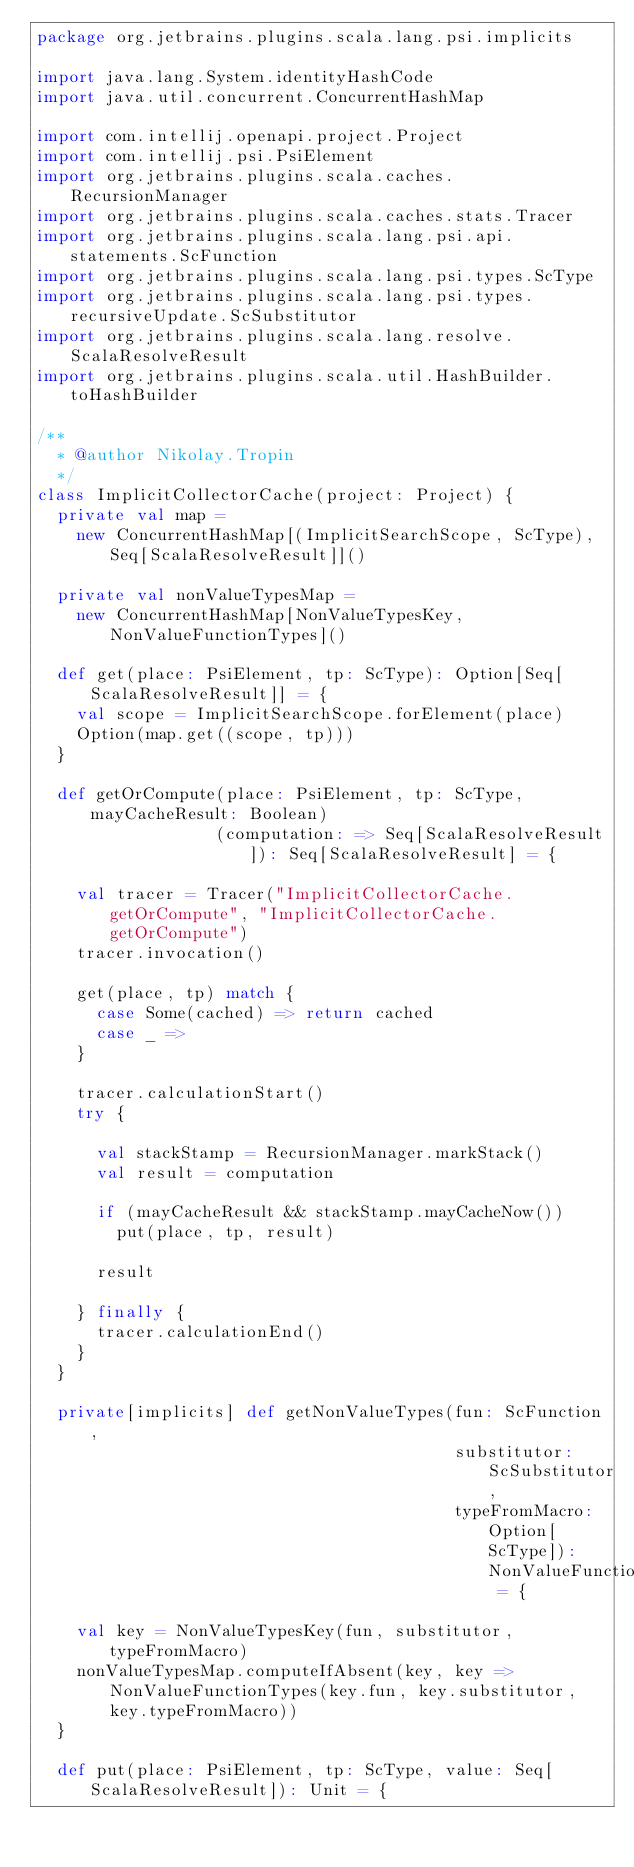Convert code to text. <code><loc_0><loc_0><loc_500><loc_500><_Scala_>package org.jetbrains.plugins.scala.lang.psi.implicits

import java.lang.System.identityHashCode
import java.util.concurrent.ConcurrentHashMap

import com.intellij.openapi.project.Project
import com.intellij.psi.PsiElement
import org.jetbrains.plugins.scala.caches.RecursionManager
import org.jetbrains.plugins.scala.caches.stats.Tracer
import org.jetbrains.plugins.scala.lang.psi.api.statements.ScFunction
import org.jetbrains.plugins.scala.lang.psi.types.ScType
import org.jetbrains.plugins.scala.lang.psi.types.recursiveUpdate.ScSubstitutor
import org.jetbrains.plugins.scala.lang.resolve.ScalaResolveResult
import org.jetbrains.plugins.scala.util.HashBuilder.toHashBuilder

/**
  * @author Nikolay.Tropin
  */
class ImplicitCollectorCache(project: Project) {
  private val map =
    new ConcurrentHashMap[(ImplicitSearchScope, ScType), Seq[ScalaResolveResult]]()

  private val nonValueTypesMap =
    new ConcurrentHashMap[NonValueTypesKey, NonValueFunctionTypes]()

  def get(place: PsiElement, tp: ScType): Option[Seq[ScalaResolveResult]] = {
    val scope = ImplicitSearchScope.forElement(place)
    Option(map.get((scope, tp)))
  }

  def getOrCompute(place: PsiElement, tp: ScType, mayCacheResult: Boolean)
                  (computation: => Seq[ScalaResolveResult]): Seq[ScalaResolveResult] = {

    val tracer = Tracer("ImplicitCollectorCache.getOrCompute", "ImplicitCollectorCache.getOrCompute")
    tracer.invocation()

    get(place, tp) match {
      case Some(cached) => return cached
      case _ =>
    }

    tracer.calculationStart()
    try {

      val stackStamp = RecursionManager.markStack()
      val result = computation

      if (mayCacheResult && stackStamp.mayCacheNow())
        put(place, tp, result)

      result

    } finally {
      tracer.calculationEnd()
    }
  }

  private[implicits] def getNonValueTypes(fun: ScFunction,
                                          substitutor: ScSubstitutor,
                                          typeFromMacro: Option[ScType]): NonValueFunctionTypes = {

    val key = NonValueTypesKey(fun, substitutor, typeFromMacro)
    nonValueTypesMap.computeIfAbsent(key, key => NonValueFunctionTypes(key.fun, key.substitutor, key.typeFromMacro))
  }

  def put(place: PsiElement, tp: ScType, value: Seq[ScalaResolveResult]): Unit = {</code> 